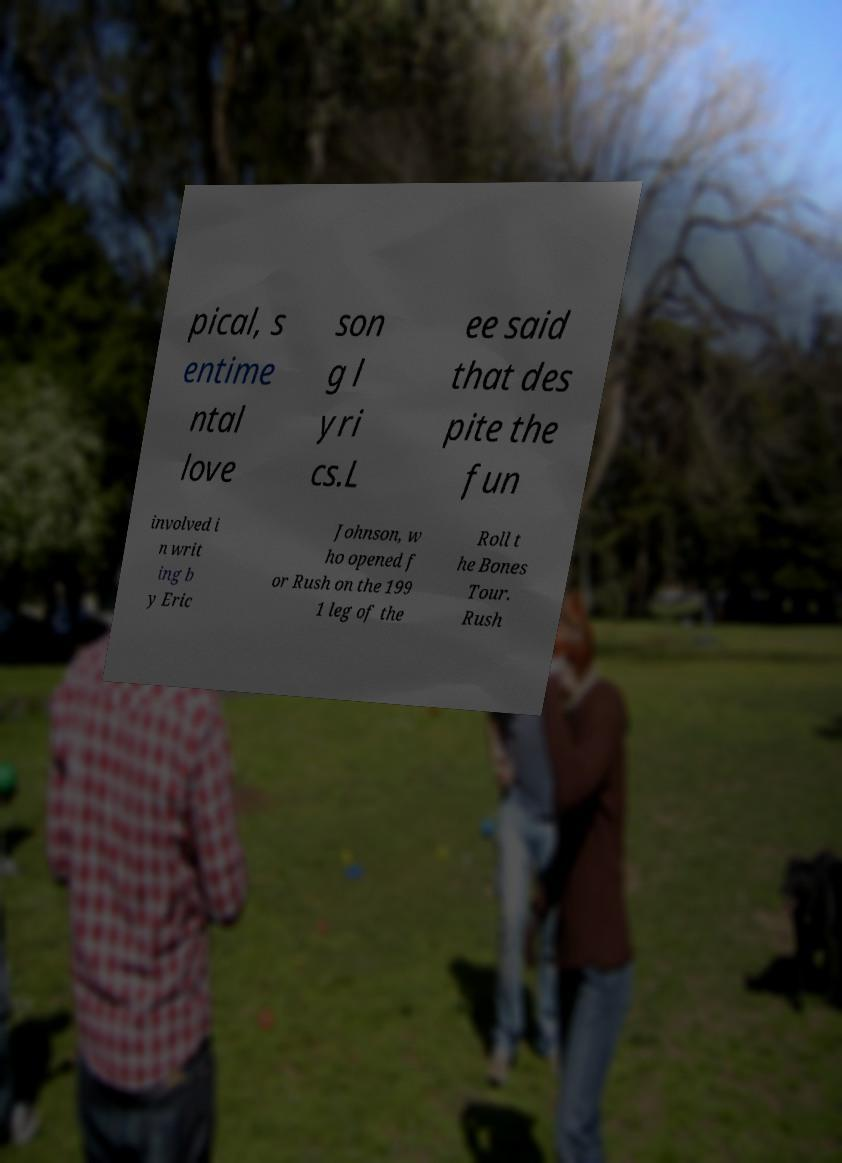Could you assist in decoding the text presented in this image and type it out clearly? pical, s entime ntal love son g l yri cs.L ee said that des pite the fun involved i n writ ing b y Eric Johnson, w ho opened f or Rush on the 199 1 leg of the Roll t he Bones Tour. Rush 